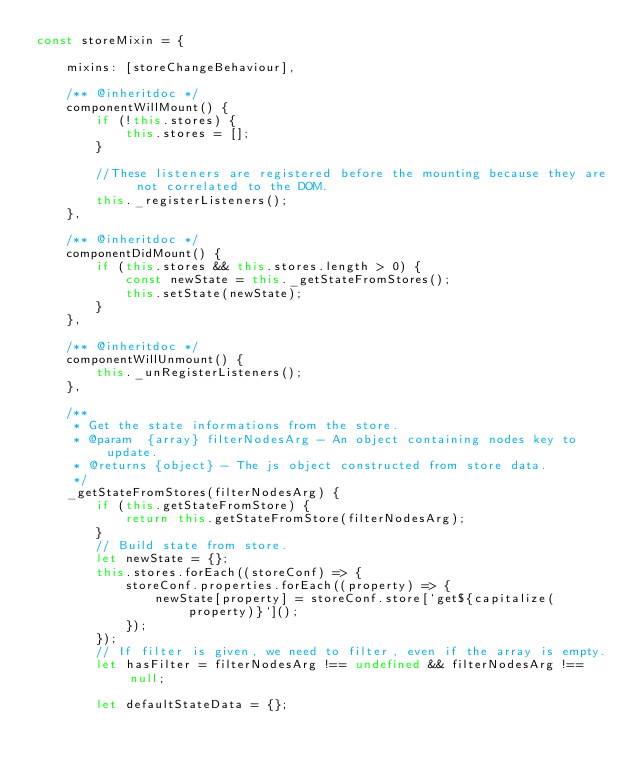<code> <loc_0><loc_0><loc_500><loc_500><_JavaScript_>const storeMixin = {

    mixins: [storeChangeBehaviour],

    /** @inheritdoc */
    componentWillMount() {
        if (!this.stores) {
            this.stores = [];
        }

        //These listeners are registered before the mounting because they are not correlated to the DOM.
        this._registerListeners();
    },

    /** @inheritdoc */
    componentDidMount() {
        if (this.stores && this.stores.length > 0) {
            const newState = this._getStateFromStores();
            this.setState(newState);
        }
    },

    /** @inheritdoc */
    componentWillUnmount() {
        this._unRegisterListeners();
    },

    /**
     * Get the state informations from the store.
     * @param  {array} filterNodesArg - An object containing nodes key to update.
     * @returns {object} - The js object constructed from store data.
     */
    _getStateFromStores(filterNodesArg) {
        if (this.getStateFromStore) {
            return this.getStateFromStore(filterNodesArg);
        }
        // Build state from store.
        let newState = {};
        this.stores.forEach((storeConf) => {
            storeConf.properties.forEach((property) => {
                newState[property] = storeConf.store[`get${capitalize(property)}`]();
            });
        });
        // If filter is given, we need to filter, even if the array is empty.
        let hasFilter = filterNodesArg !== undefined && filterNodesArg !== null;

        let defaultStateData = {};</code> 